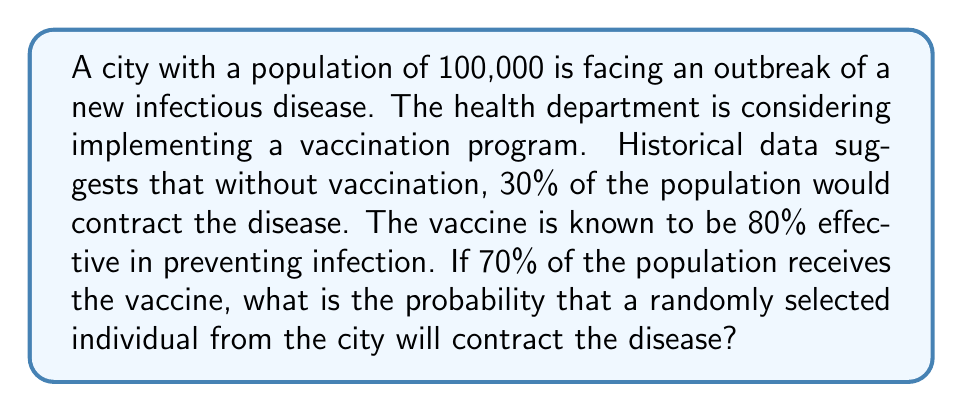Help me with this question. Let's approach this problem step by step using probability theory:

1) First, let's define our events:
   A: The individual is vaccinated
   B: The individual contracts the disease

2) We're given the following probabilities:
   P(A) = 0.70 (70% of the population is vaccinated)
   P(B|not A) = 0.30 (30% chance of contracting the disease if not vaccinated)
   P(not B|A) = 0.80 (vaccine is 80% effective, so 80% chance of not contracting if vaccinated)

3) We need to find P(B), which we can calculate using the law of total probability:

   $$P(B) = P(B|A) \cdot P(A) + P(B|not A) \cdot P(not A)$$

4) We know P(A) = 0.70, so P(not A) = 1 - 0.70 = 0.30

5) We're given P(not B|A) = 0.80, so P(B|A) = 1 - 0.80 = 0.20

6) Now we can plug these values into our equation:

   $$P(B) = 0.20 \cdot 0.70 + 0.30 \cdot 0.30$$

7) Calculating:
   $$P(B) = 0.14 + 0.09 = 0.23$$

Therefore, the probability that a randomly selected individual will contract the disease is 0.23 or 23%.
Answer: 0.23 or 23% 